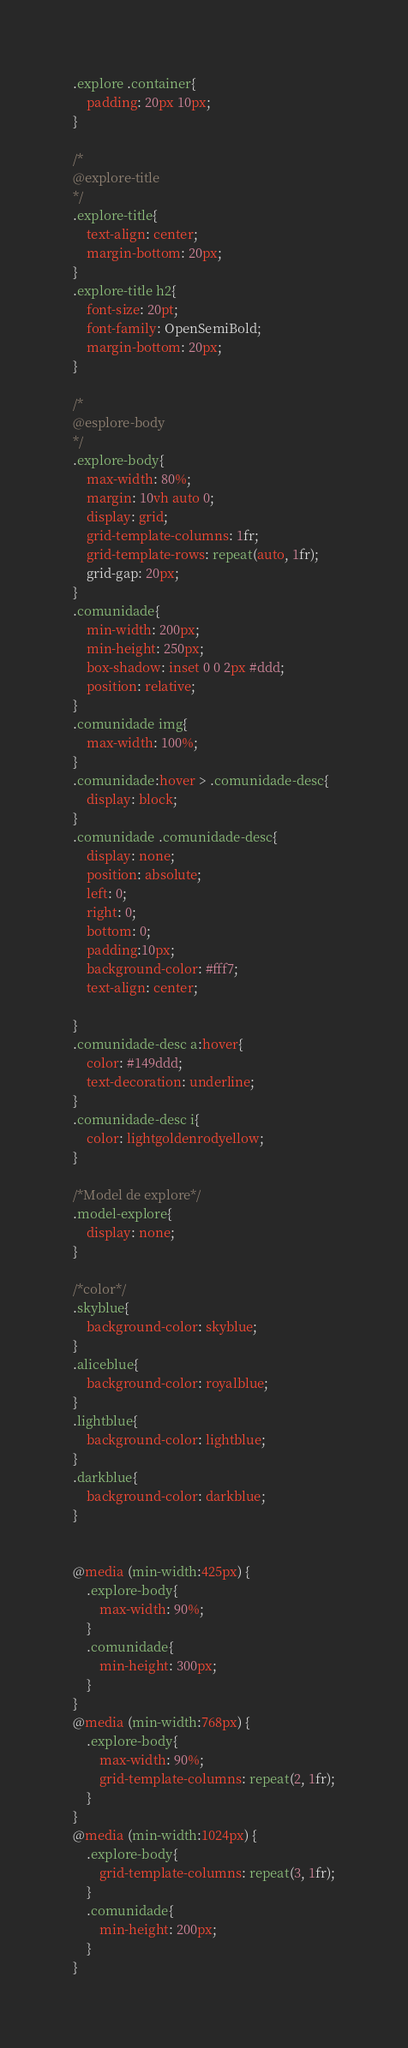Convert code to text. <code><loc_0><loc_0><loc_500><loc_500><_CSS_>.explore .container{
	padding: 20px 10px;
}

/*
@explore-title
*/
.explore-title{
	text-align: center;
	margin-bottom: 20px;
}
.explore-title h2{
	font-size: 20pt;
	font-family: OpenSemiBold;
	margin-bottom: 20px;
}

/*
@esplore-body
*/
.explore-body{
	max-width: 80%;
	margin: 10vh auto 0;
	display: grid;
	grid-template-columns: 1fr;
	grid-template-rows: repeat(auto, 1fr);
	grid-gap: 20px;
}
.comunidade{
	min-width: 200px;
	min-height: 250px;
	box-shadow: inset 0 0 2px #ddd;
	position: relative;
}
.comunidade img{
	max-width: 100%;
}
.comunidade:hover > .comunidade-desc{
	display: block;
}
.comunidade .comunidade-desc{
	display: none;
	position: absolute;
	left: 0;
	right: 0;
	bottom: 0;
	padding:10px;
	background-color: #fff7;
	text-align: center;

}
.comunidade-desc a:hover{
	color: #149ddd;
	text-decoration: underline;
}
.comunidade-desc i{
	color: lightgoldenrodyellow;
}

/*Model de explore*/
.model-explore{
	display: none;
}

/*color*/
.skyblue{
	background-color: skyblue;
}
.aliceblue{
	background-color: royalblue;
}
.lightblue{
	background-color: lightblue;
}
.darkblue{
	background-color: darkblue;
}


@media (min-width:425px) {
	.explore-body{
		max-width: 90%;
	}
	.comunidade{
		min-height: 300px;
	}
}
@media (min-width:768px) {
	.explore-body{
		max-width: 90%;
		grid-template-columns: repeat(2, 1fr);
	}
}
@media (min-width:1024px) {
	.explore-body{
		grid-template-columns: repeat(3, 1fr);
	}
	.comunidade{
		min-height: 200px;
	}
}</code> 